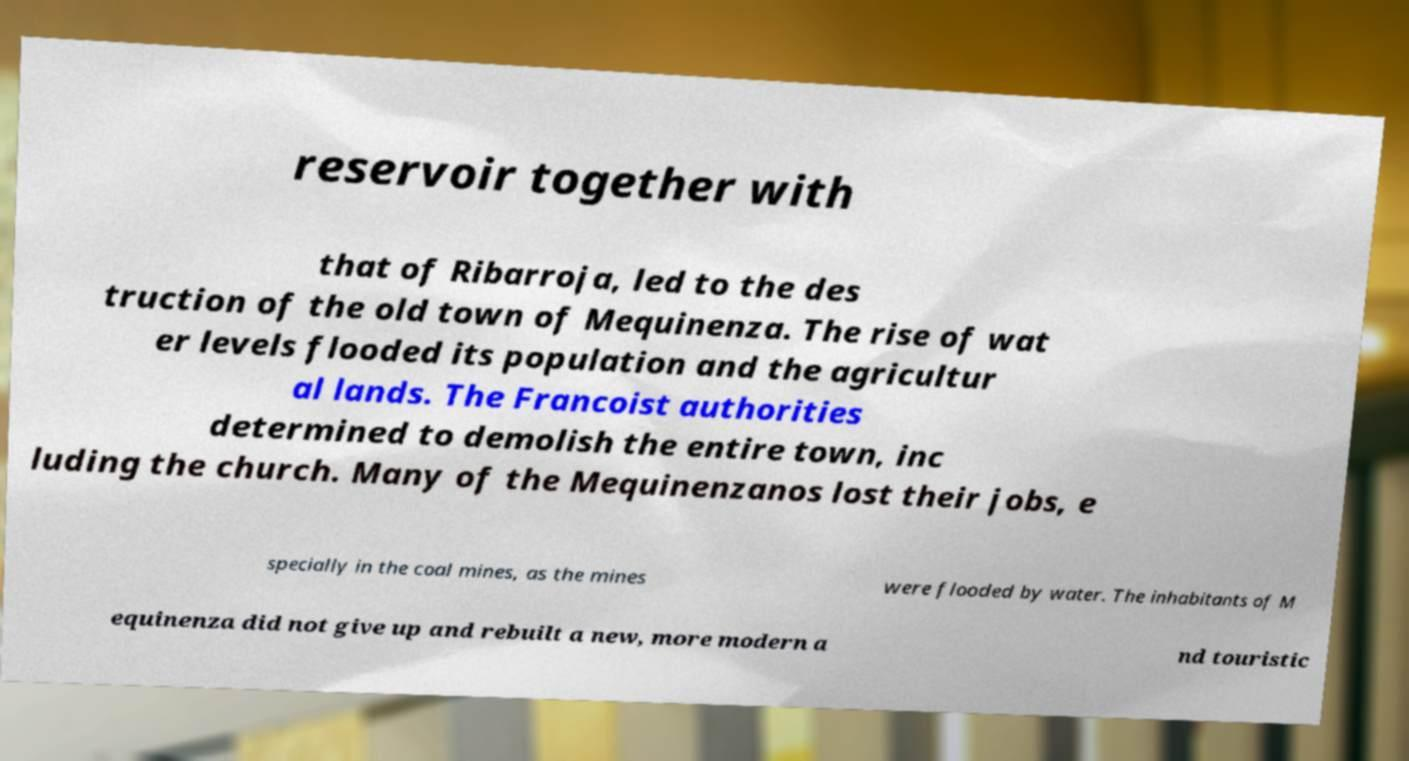Please read and relay the text visible in this image. What does it say? reservoir together with that of Ribarroja, led to the des truction of the old town of Mequinenza. The rise of wat er levels flooded its population and the agricultur al lands. The Francoist authorities determined to demolish the entire town, inc luding the church. Many of the Mequinenzanos lost their jobs, e specially in the coal mines, as the mines were flooded by water. The inhabitants of M equinenza did not give up and rebuilt a new, more modern a nd touristic 